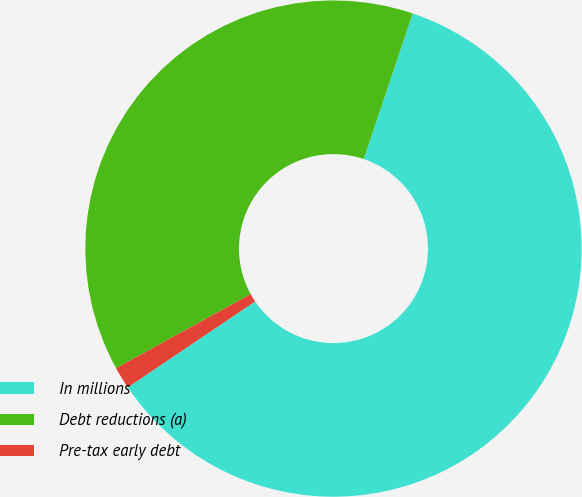Convert chart. <chart><loc_0><loc_0><loc_500><loc_500><pie_chart><fcel>In millions<fcel>Debt reductions (a)<fcel>Pre-tax early debt<nl><fcel>60.38%<fcel>38.18%<fcel>1.44%<nl></chart> 